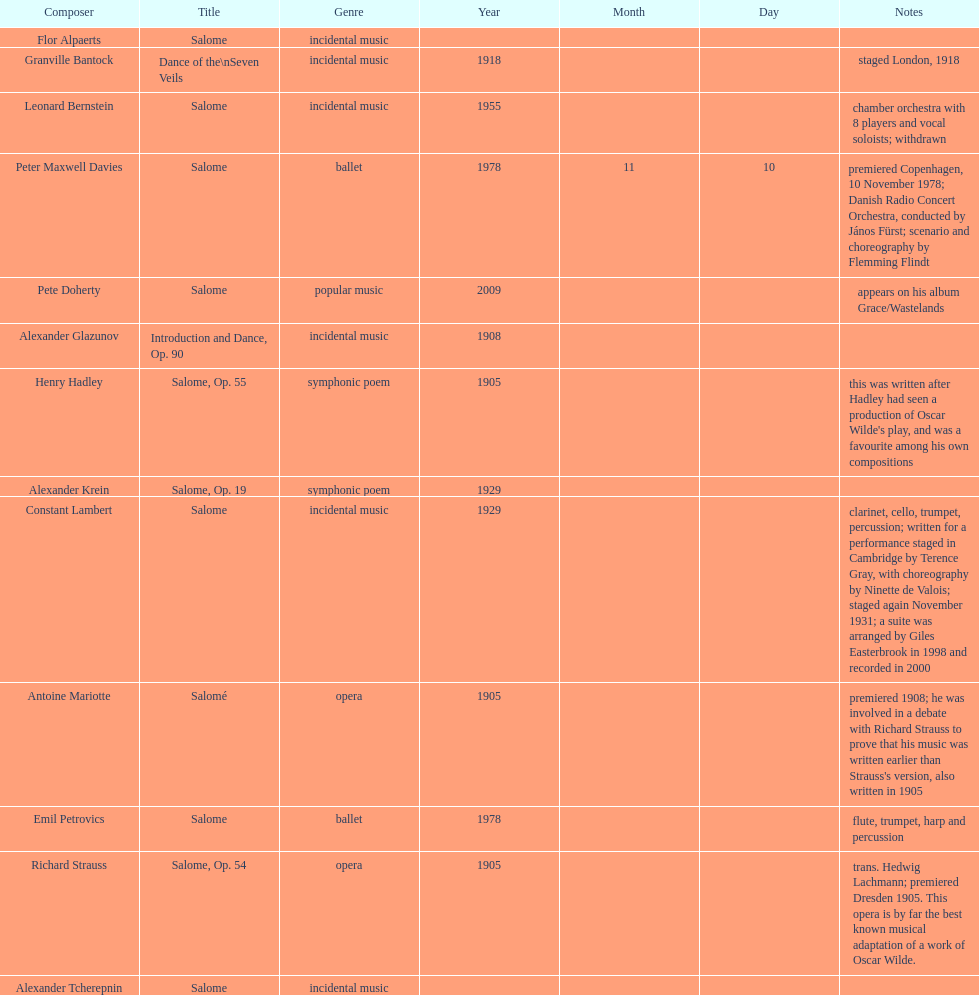Who is next on the list after alexander krein? Constant Lambert. 